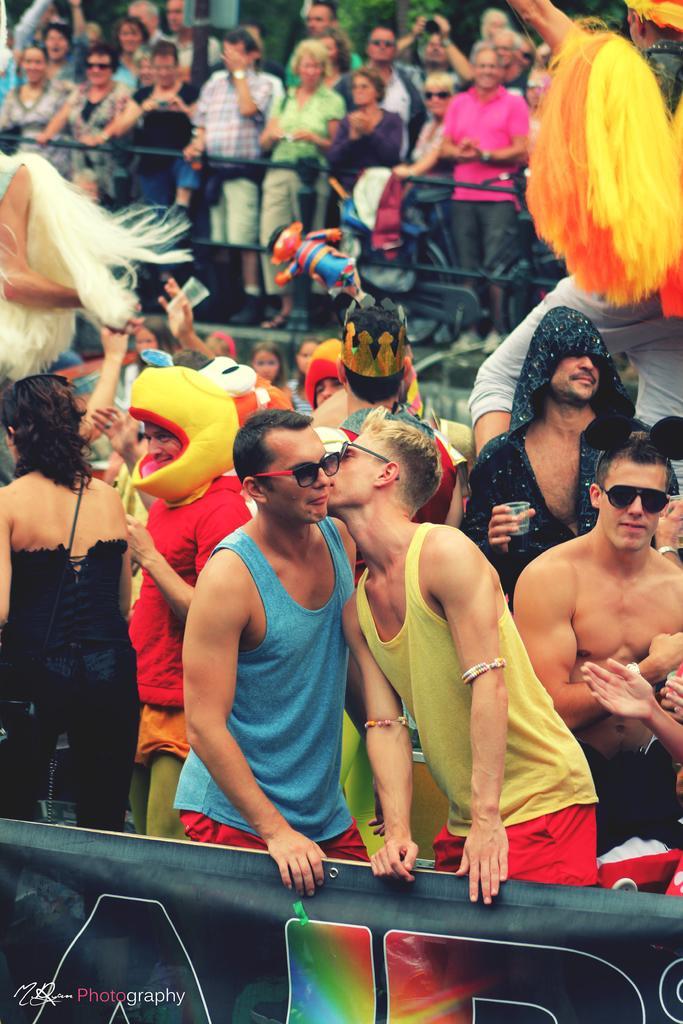Please provide a concise description of this image. In this image, we can see some people standing and wearing clothes. There is a banner at the bottom of the image. 